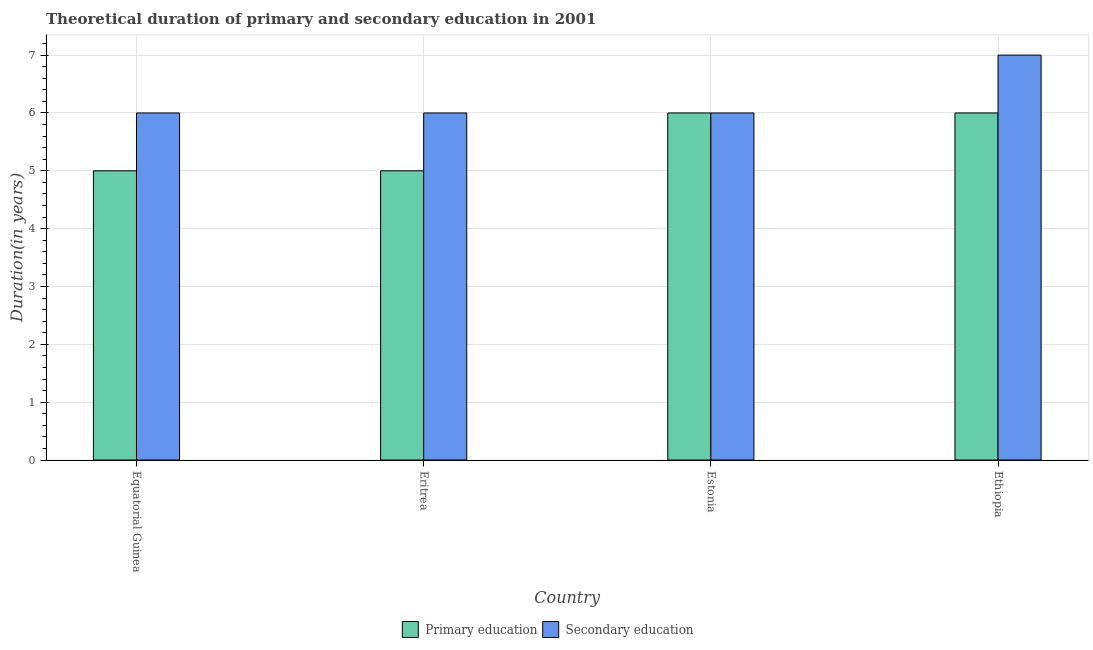How many different coloured bars are there?
Your answer should be very brief. 2. Are the number of bars per tick equal to the number of legend labels?
Provide a short and direct response. Yes. How many bars are there on the 2nd tick from the left?
Your answer should be compact. 2. What is the label of the 3rd group of bars from the left?
Make the answer very short. Estonia. In how many cases, is the number of bars for a given country not equal to the number of legend labels?
Provide a succinct answer. 0. What is the duration of primary education in Ethiopia?
Give a very brief answer. 6. Across all countries, what is the maximum duration of secondary education?
Provide a short and direct response. 7. In which country was the duration of secondary education maximum?
Keep it short and to the point. Ethiopia. In which country was the duration of secondary education minimum?
Your answer should be compact. Equatorial Guinea. What is the total duration of secondary education in the graph?
Your answer should be compact. 25. What is the difference between the duration of primary education in Equatorial Guinea and that in Estonia?
Offer a terse response. -1. What is the difference between the duration of primary education in Estonia and the duration of secondary education in Equatorial Guinea?
Your response must be concise. 0. What is the difference between the duration of secondary education and duration of primary education in Equatorial Guinea?
Offer a very short reply. 1. What is the ratio of the duration of primary education in Eritrea to that in Estonia?
Keep it short and to the point. 0.83. Is the duration of primary education in Eritrea less than that in Estonia?
Offer a very short reply. Yes. What is the difference between the highest and the lowest duration of primary education?
Your response must be concise. 1. What does the 1st bar from the left in Eritrea represents?
Your response must be concise. Primary education. What does the 2nd bar from the right in Ethiopia represents?
Your answer should be very brief. Primary education. How many bars are there?
Provide a short and direct response. 8. Are all the bars in the graph horizontal?
Your response must be concise. No. How many countries are there in the graph?
Give a very brief answer. 4. Are the values on the major ticks of Y-axis written in scientific E-notation?
Provide a short and direct response. No. Does the graph contain any zero values?
Provide a short and direct response. No. Does the graph contain grids?
Provide a succinct answer. Yes. How many legend labels are there?
Provide a short and direct response. 2. What is the title of the graph?
Provide a short and direct response. Theoretical duration of primary and secondary education in 2001. What is the label or title of the X-axis?
Provide a short and direct response. Country. What is the label or title of the Y-axis?
Keep it short and to the point. Duration(in years). What is the Duration(in years) in Primary education in Eritrea?
Provide a short and direct response. 5. What is the Duration(in years) of Primary education in Estonia?
Keep it short and to the point. 6. What is the Duration(in years) of Secondary education in Estonia?
Offer a terse response. 6. What is the Duration(in years) in Primary education in Ethiopia?
Your answer should be very brief. 6. Across all countries, what is the maximum Duration(in years) in Primary education?
Keep it short and to the point. 6. Across all countries, what is the maximum Duration(in years) in Secondary education?
Offer a very short reply. 7. What is the total Duration(in years) in Primary education in the graph?
Your answer should be very brief. 22. What is the difference between the Duration(in years) in Primary education in Equatorial Guinea and that in Eritrea?
Provide a short and direct response. 0. What is the difference between the Duration(in years) in Primary education in Equatorial Guinea and that in Estonia?
Provide a short and direct response. -1. What is the difference between the Duration(in years) of Secondary education in Equatorial Guinea and that in Estonia?
Your answer should be very brief. 0. What is the difference between the Duration(in years) in Secondary education in Eritrea and that in Estonia?
Ensure brevity in your answer.  0. What is the difference between the Duration(in years) in Primary education in Estonia and that in Ethiopia?
Provide a short and direct response. 0. What is the difference between the Duration(in years) in Secondary education in Estonia and that in Ethiopia?
Your response must be concise. -1. What is the difference between the Duration(in years) of Primary education in Equatorial Guinea and the Duration(in years) of Secondary education in Eritrea?
Your answer should be very brief. -1. What is the average Duration(in years) of Primary education per country?
Keep it short and to the point. 5.5. What is the average Duration(in years) in Secondary education per country?
Offer a very short reply. 6.25. What is the difference between the Duration(in years) of Primary education and Duration(in years) of Secondary education in Equatorial Guinea?
Your answer should be very brief. -1. What is the difference between the Duration(in years) in Primary education and Duration(in years) in Secondary education in Eritrea?
Provide a succinct answer. -1. What is the ratio of the Duration(in years) of Primary education in Equatorial Guinea to that in Eritrea?
Your answer should be compact. 1. What is the ratio of the Duration(in years) in Secondary education in Equatorial Guinea to that in Estonia?
Your response must be concise. 1. What is the ratio of the Duration(in years) of Primary education in Equatorial Guinea to that in Ethiopia?
Make the answer very short. 0.83. What is the ratio of the Duration(in years) of Primary education in Eritrea to that in Estonia?
Your answer should be compact. 0.83. What is the difference between the highest and the second highest Duration(in years) in Secondary education?
Give a very brief answer. 1. What is the difference between the highest and the lowest Duration(in years) in Primary education?
Give a very brief answer. 1. 